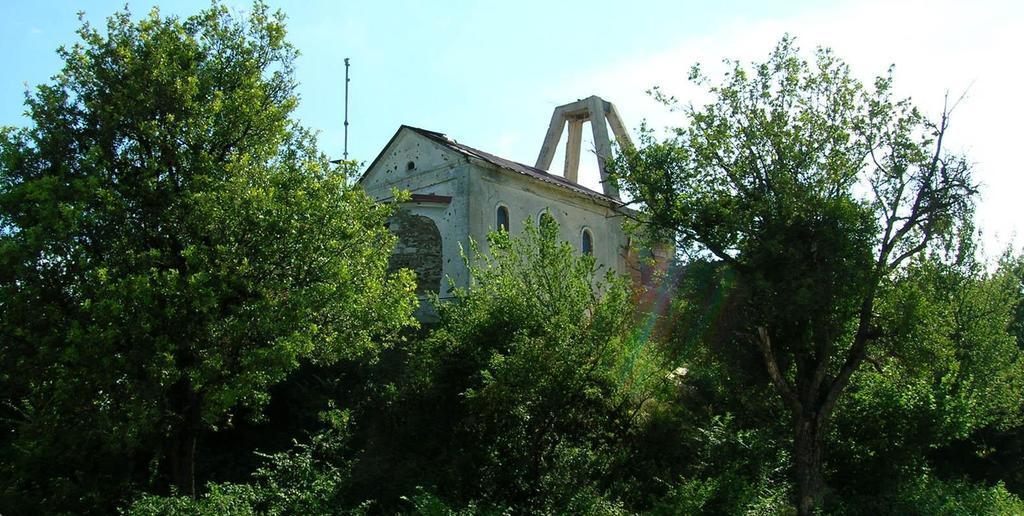Could you give a brief overview of what you see in this image? In this image, we can see some green color trees and there is a house, at the top there is a blue color sky. 